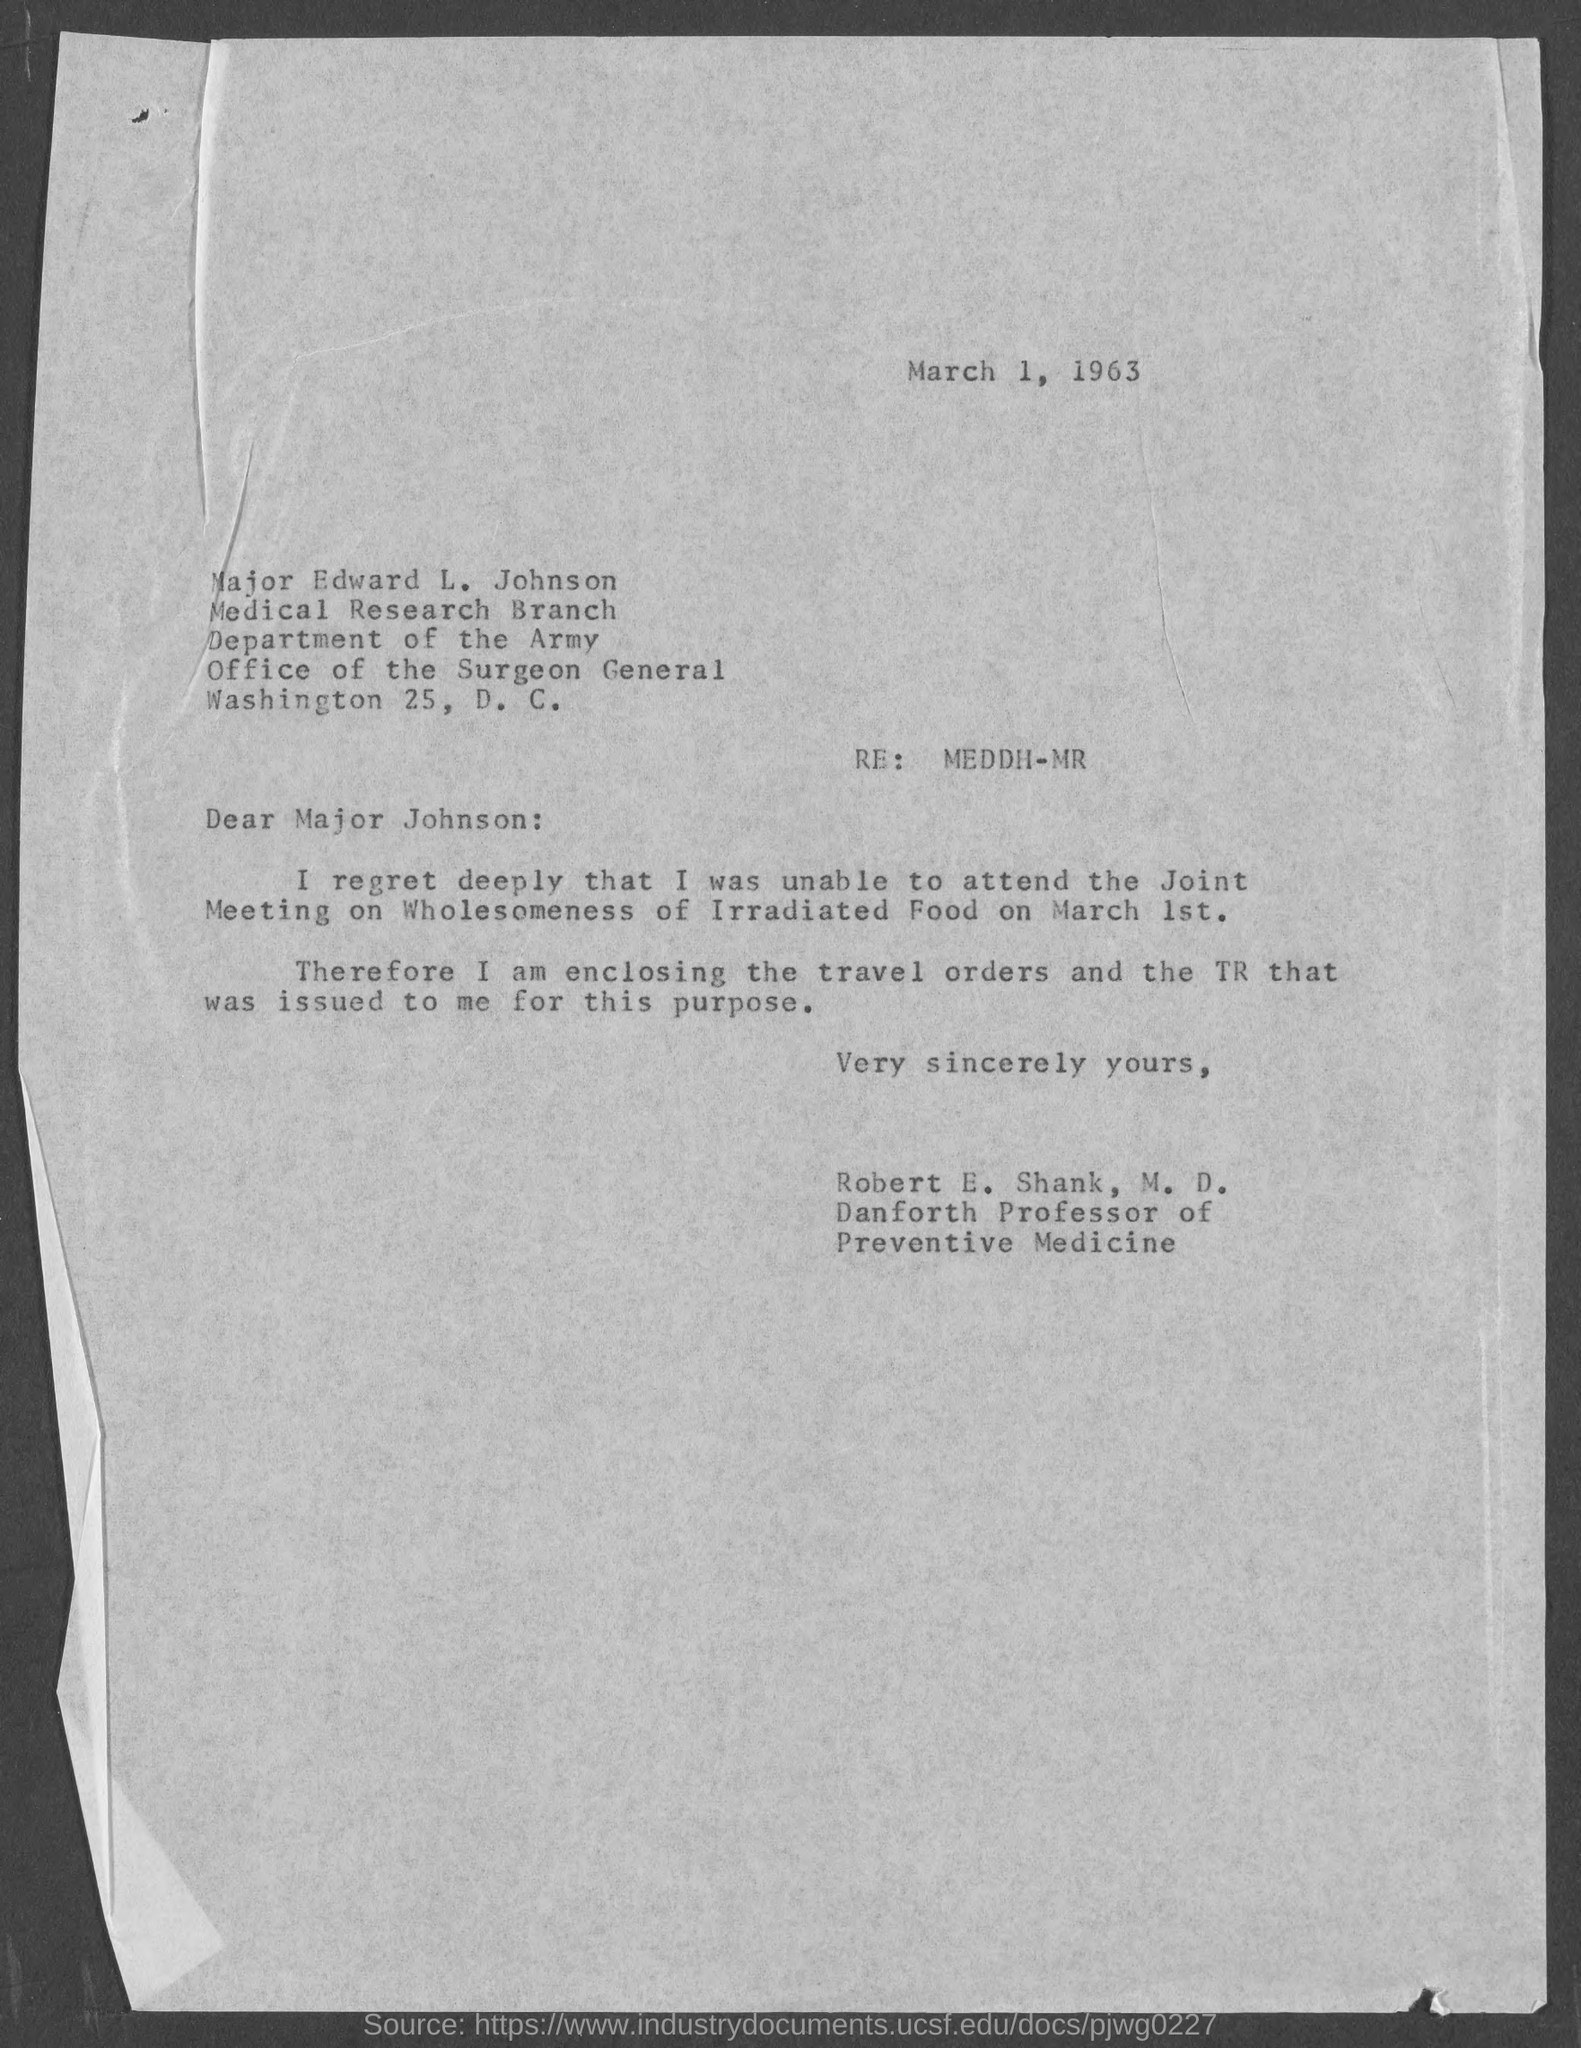What is the date mentioned in the top of the document ?
Give a very brief answer. March 1, 1963. Who is the memorandum to ?
Offer a terse response. Major Johnson. 